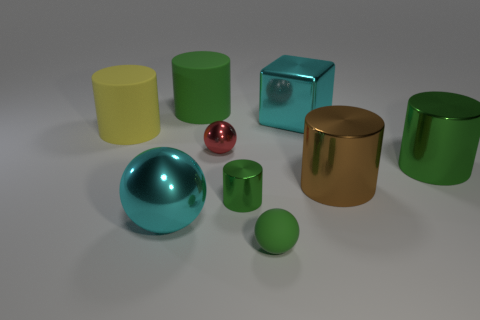What number of cylinders are brown objects or cyan things?
Your answer should be compact. 1. What is the color of the small matte thing?
Your response must be concise. Green. Is the size of the cyan thing that is behind the large yellow thing the same as the metal ball that is to the left of the red sphere?
Provide a succinct answer. Yes. Is the number of big yellow cylinders less than the number of green shiny things?
Keep it short and to the point. Yes. There is a large green metallic cylinder; how many matte balls are on the left side of it?
Provide a succinct answer. 1. What material is the big yellow cylinder?
Offer a very short reply. Rubber. Do the big shiny ball and the big cube have the same color?
Provide a succinct answer. Yes. Are there fewer large things that are in front of the red shiny sphere than big metal balls?
Your answer should be compact. No. The large rubber thing that is behind the large yellow rubber cylinder is what color?
Keep it short and to the point. Green. There is a yellow rubber thing; what shape is it?
Your response must be concise. Cylinder. 